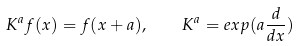<formula> <loc_0><loc_0><loc_500><loc_500>K ^ { a } f ( x ) = f ( x + a ) , \quad K ^ { a } = e x p ( a \frac { d } { d x } )</formula> 